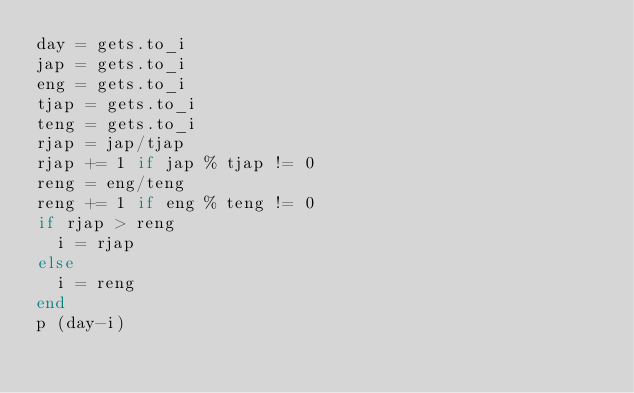<code> <loc_0><loc_0><loc_500><loc_500><_Ruby_>day = gets.to_i
jap = gets.to_i
eng = gets.to_i
tjap = gets.to_i
teng = gets.to_i
rjap = jap/tjap
rjap +=	1 if jap % tjap	!= 0
reng = eng/teng
reng +=	1 if eng % teng	!= 0
if rjap > reng
  i = rjap
else
  i = reng
end
p (day-i)


</code> 